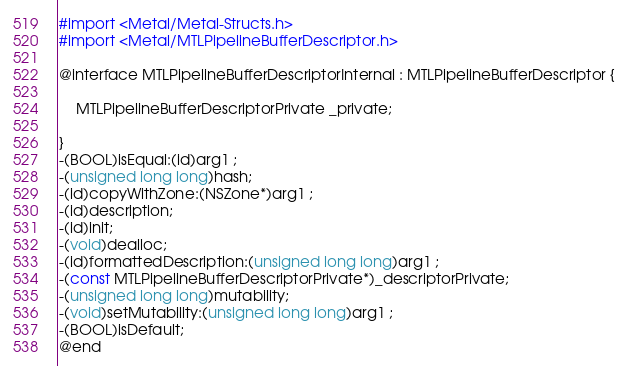Convert code to text. <code><loc_0><loc_0><loc_500><loc_500><_C_>#import <Metal/Metal-Structs.h>
#import <Metal/MTLPipelineBufferDescriptor.h>

@interface MTLPipelineBufferDescriptorInternal : MTLPipelineBufferDescriptor {

	MTLPipelineBufferDescriptorPrivate _private;

}
-(BOOL)isEqual:(id)arg1 ;
-(unsigned long long)hash;
-(id)copyWithZone:(NSZone*)arg1 ;
-(id)description;
-(id)init;
-(void)dealloc;
-(id)formattedDescription:(unsigned long long)arg1 ;
-(const MTLPipelineBufferDescriptorPrivate*)_descriptorPrivate;
-(unsigned long long)mutability;
-(void)setMutability:(unsigned long long)arg1 ;
-(BOOL)isDefault;
@end

</code> 